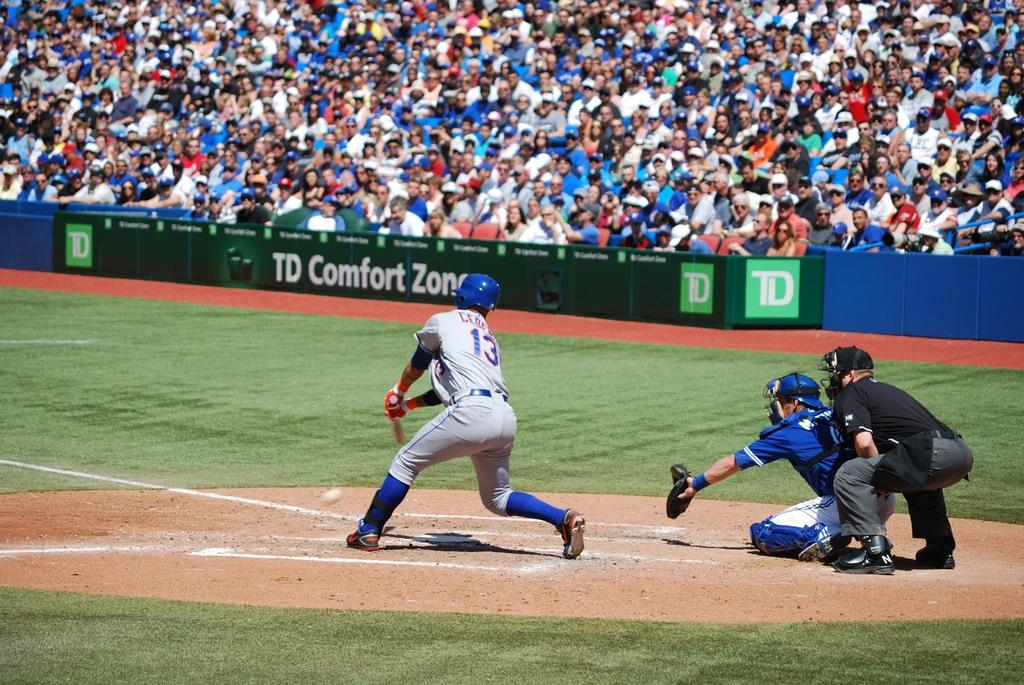<image>
Share a concise interpretation of the image provided. a man with a jersey that has the number 13 on it 